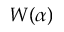<formula> <loc_0><loc_0><loc_500><loc_500>W ( \alpha )</formula> 